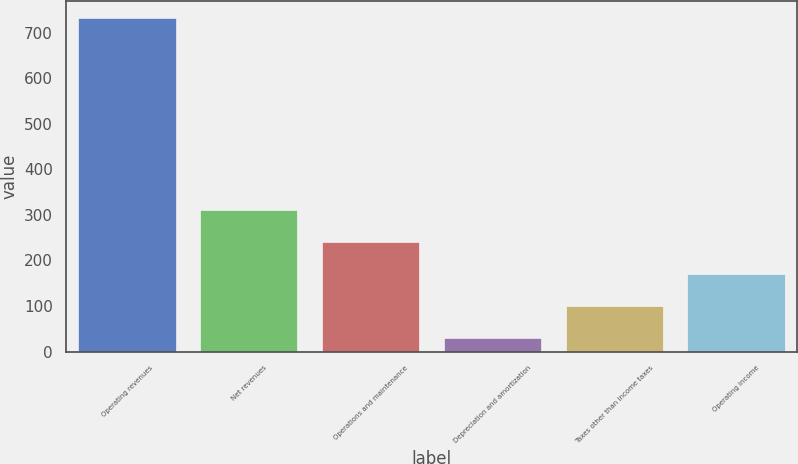Convert chart. <chart><loc_0><loc_0><loc_500><loc_500><bar_chart><fcel>Operating revenues<fcel>Net revenues<fcel>Operations and maintenance<fcel>Depreciation and amortization<fcel>Taxes other than income taxes<fcel>Operating income<nl><fcel>733<fcel>310.6<fcel>240.2<fcel>29<fcel>99.4<fcel>169.8<nl></chart> 